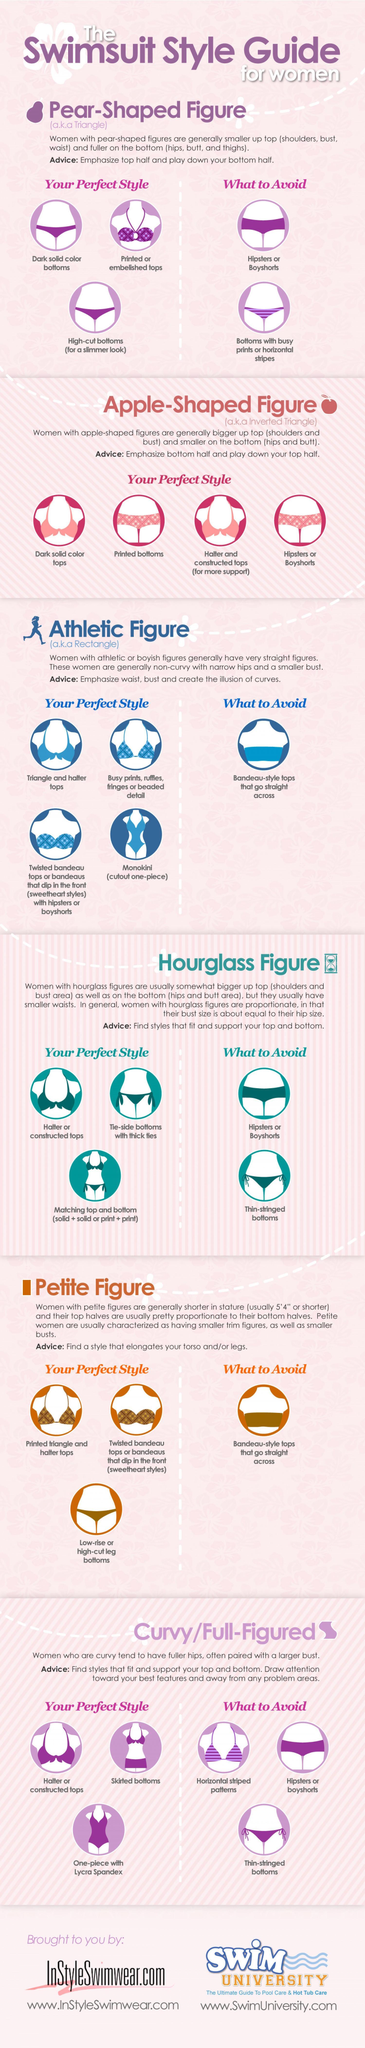Which are the two styles that women with pear shaped figures should avoid?
Answer the question with a short phrase. Hipsters or boyshorts, bottoms with busy prints or horizontal stripes Women with what type of figure, should wear one-piece with lycra spandex? Curvy/full-figured Women with what 'types' of figures, should avoid bandeau-style tops? Athletic figure, petite figure How many perfect styles are mentioned for women with pear-shaped figures? 3 Women with which type of figure, should opt to wear monokini? Athletic figure What is the advice given to women with petite figures? Find a style that elongates your torso and/or legs Women with which types of figures, should avoid wearing thin-stringed bottoms? Hourglass figure, Curvy/full-figured Which figure is also called the inverted triangle? Apple-shaped figure Which figure is also called the rectangle figure? Athletic figure How many figure types are mentioned? 6 Which figure is also called the triangle figure? Pear-shaped figure What advice is given to women with hourglass figures? Find styles that fit and support your top and bottom 